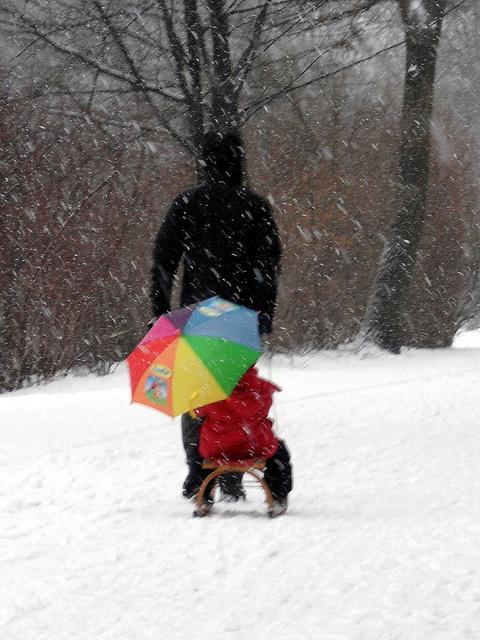What is falling from the sky?
Write a very short answer. Snow. How many colors are on the umbrella?
Write a very short answer. 8. What is on the ground?
Write a very short answer. Snow. 